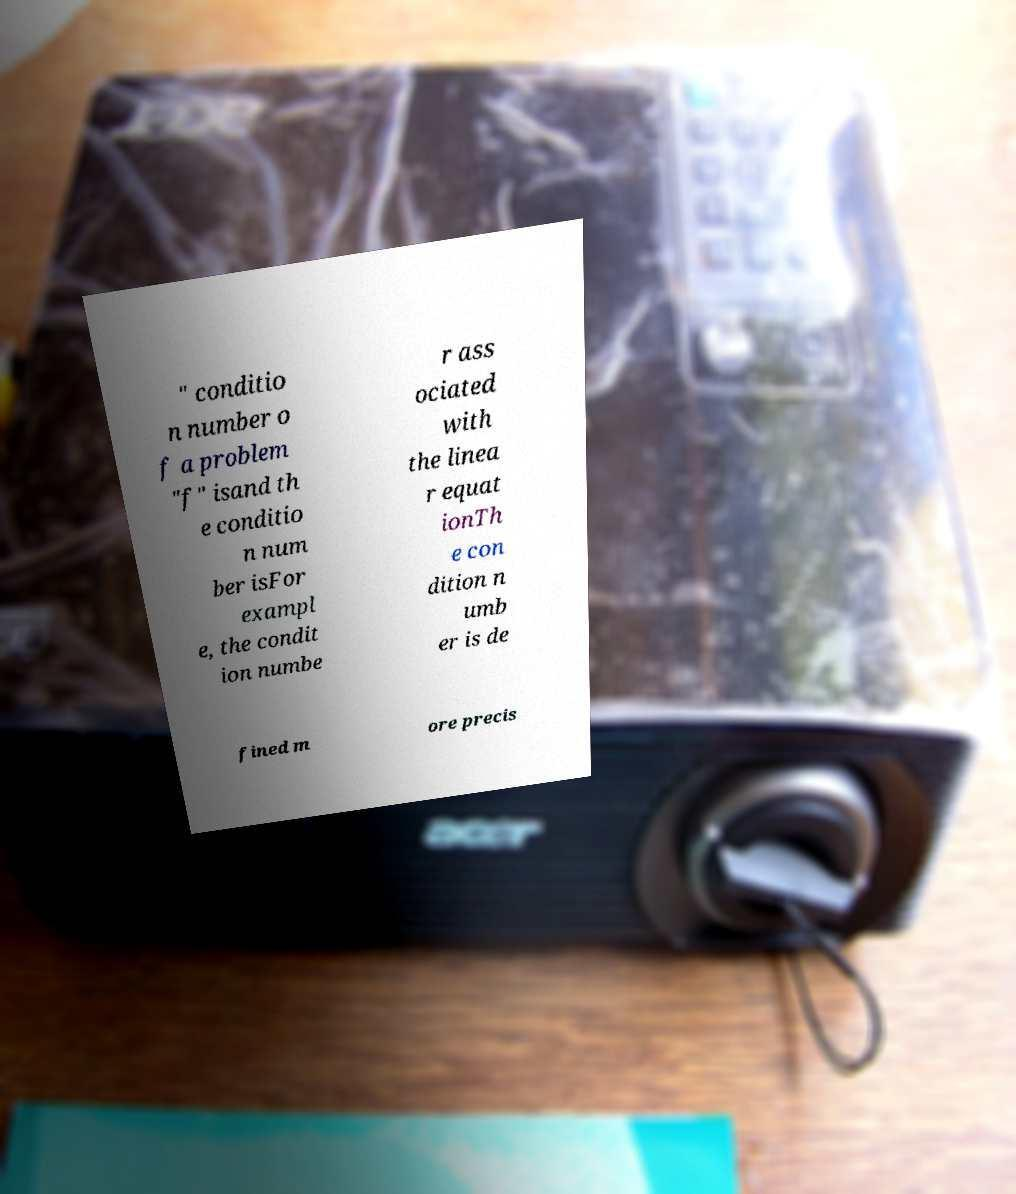What messages or text are displayed in this image? I need them in a readable, typed format. " conditio n number o f a problem "f" isand th e conditio n num ber isFor exampl e, the condit ion numbe r ass ociated with the linea r equat ionTh e con dition n umb er is de fined m ore precis 